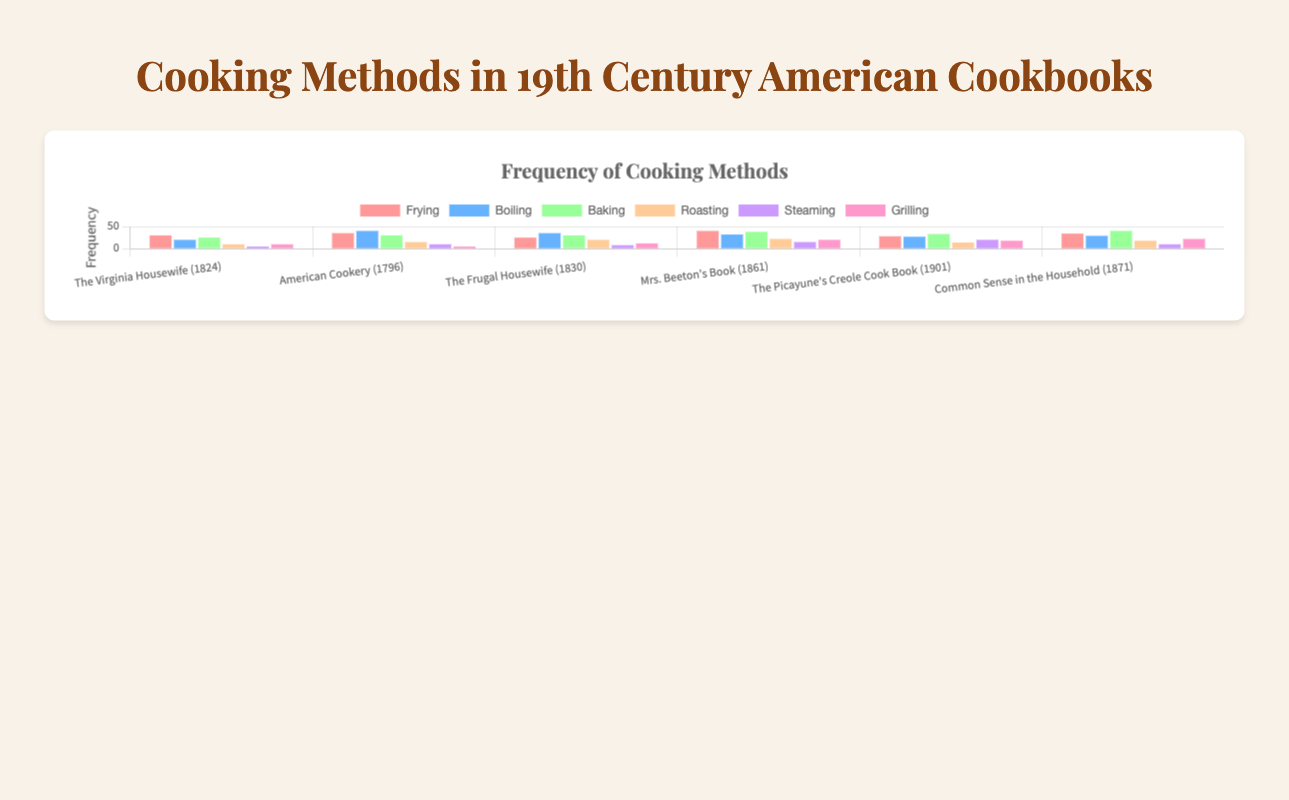Which cookbook has the highest frequency of baking? The bar representing the baking method in "Common Sense in the Household (1871)" is the tallest for baking. Therefore, it has the highest frequency.
Answer: Common Sense in the Household (1871) Which cooking method has the highest frequency in "The Virginia Housewife (1824)"? The frying bar is the tallest among all bars for "The Virginia Housewife (1824)" indicating frying has the highest frequency.
Answer: Frying Does "American Cookery (1796)" have more instances of boiling or grilling? Comparing the bars for boiling and grilling in "American Cookery (1796)", the boiling bar is much taller. Therefore, boiling has more instances.
Answer: Boiling For "Mrs. Beeton's Book (1861)", what is the difference in frequency between frying and steaming? The frying bar is at 40 and the steaming bar is at 15. The difference is calculated as 40 - 15.
Answer: 25 What is the total frequency of roasting across all cookbooks? Summing up the frequencies for roasting from all cookbooks: 10 (Virginia) + 15 (American) + 20 (Frugal) + 22 (Beeton) + 14 (Picayune) + 18 (Common Sense) = 99.
Answer: 99 Which cookbook has the fewest instances of grilling? By comparing the heights of the bars for grilling across all cookbooks, "American Cookery (1796)" has the shortest bar for grilling.
Answer: American Cookery (1796) Is the frequency of steaming in "The Picayune's Creole Cook Book (1901)" higher than in "The Virginia Housewife (1824)"? The steaming bar for "The Picayune's Creole Cook Book (1901)" is much taller than the one for "The Virginia Housewife (1824)", indicating a higher frequency.
Answer: Yes What is the average frequency of baking across all cookbooks? Summing the baking frequencies: 25 + 30 + 30 + 38 + 33 + 40 = 196. Dividing by the number of cookbooks (6) gives 196 / 6.
Answer: 32.67 Which cooking method had the highest total frequency across all cookbooks combined? Summing frequencies for each method across all cookbooks: 
Frying: 30 + 35 + 25 + 40 + 28 + 34 = 192;
Boiling: 20 + 40 + 35 + 32 + 27 + 29 = 183;
Baking: 25 + 30 + 30 + 38 + 33 + 40 = 196;
Roasting: 10 + 15 + 20 + 22 + 14 + 18 = 99;
Steaming: 5 + 10 + 8 + 15 + 20 + 10 = 68;
Grilling: 10 + 5 + 12 + 20 + 18 + 22 = 87.
Baking has the highest total frequency with 196.
Answer: Baking What is the median frequency of grilling across all cookbooks? The frequencies for grilling are: 10, 5, 12, 20, 18, 22. Arranging them in order gives 5, 10, 12, 18, 20, 22. The median is the average of the middle two numbers (12 and 18).
Answer: 15 